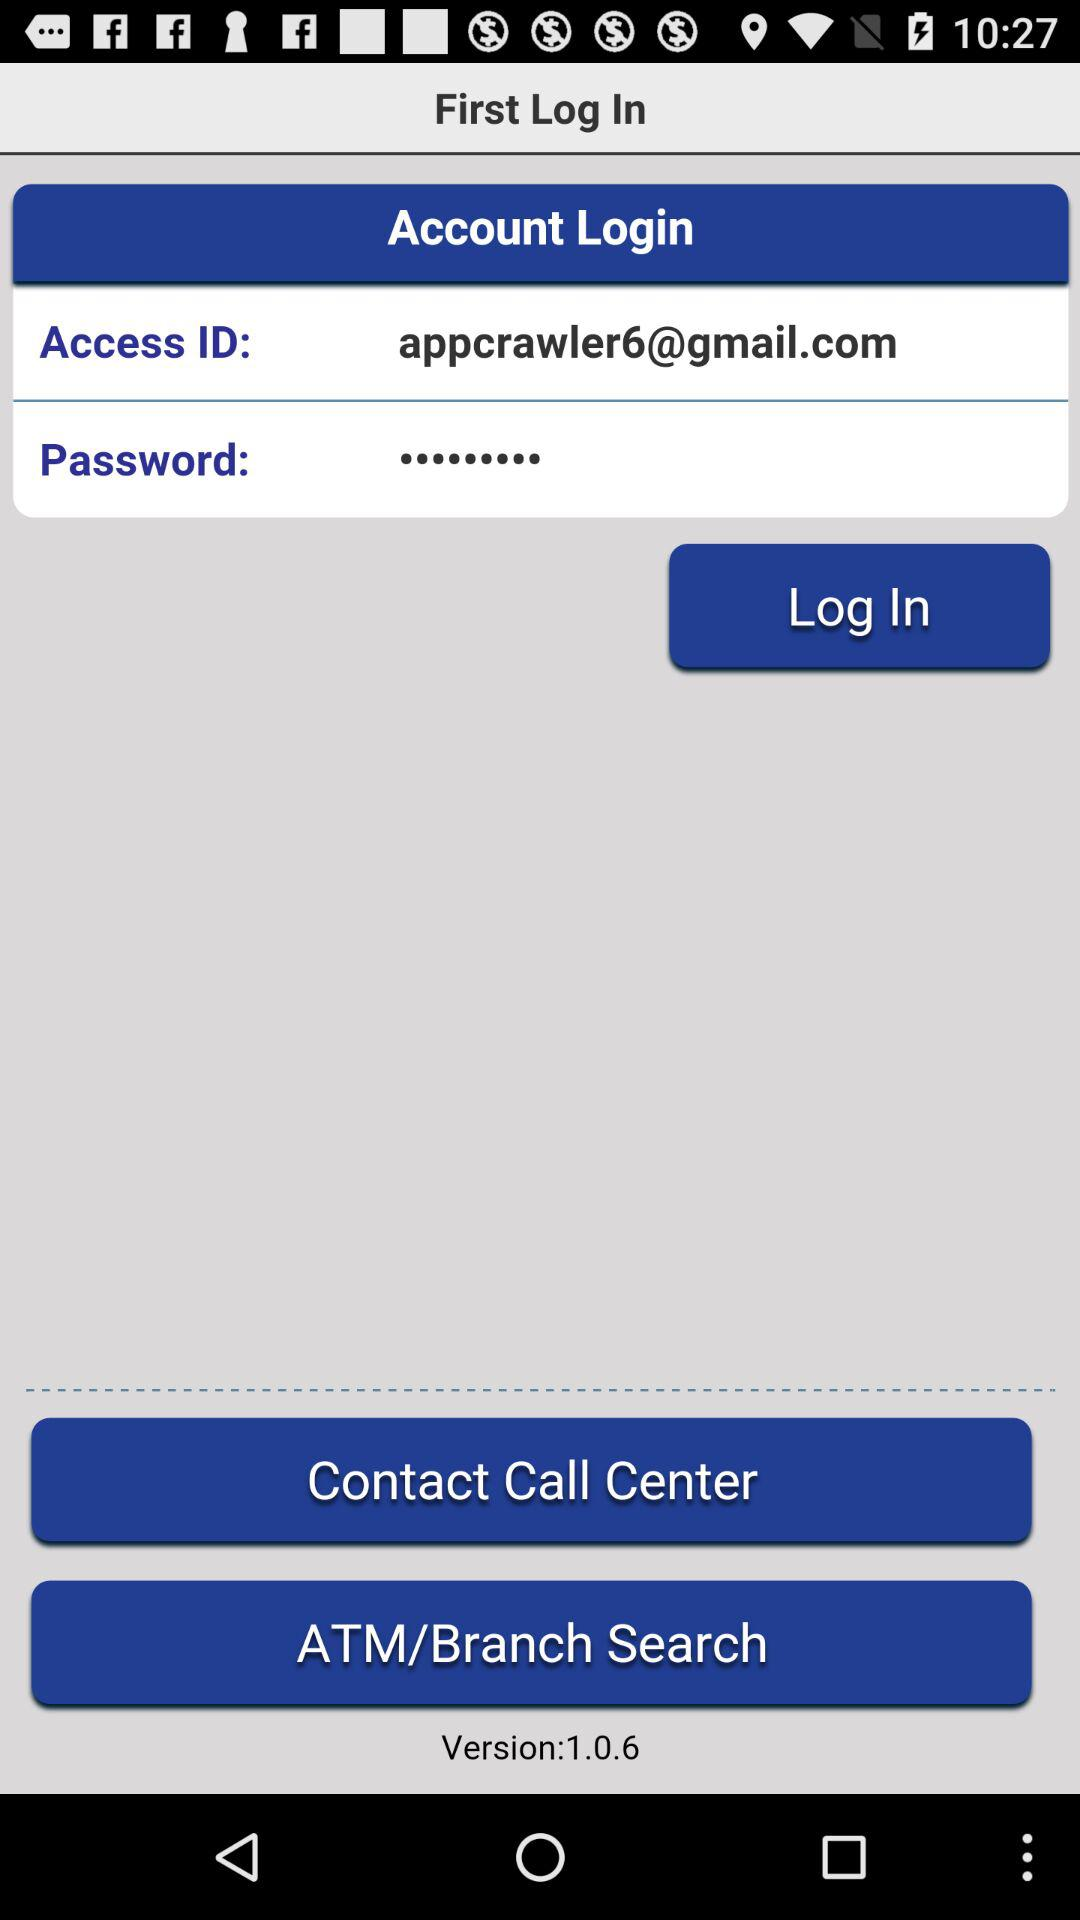What is the version of the application being used? The version of the application being used is 1.0.6. 